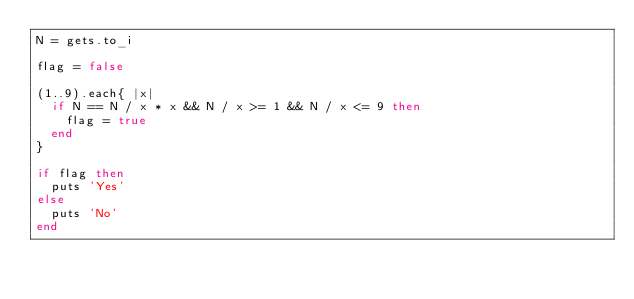<code> <loc_0><loc_0><loc_500><loc_500><_Ruby_>N = gets.to_i

flag = false

(1..9).each{ |x|
	if N == N / x * x && N / x >= 1 && N / x <= 9 then
		flag = true
	end
}

if flag then
	puts 'Yes'
else
	puts 'No'
end</code> 